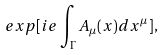<formula> <loc_0><loc_0><loc_500><loc_500>e x p [ i e \int _ { \Gamma } A _ { \mu } ( x ) d x ^ { \mu } ] ,</formula> 